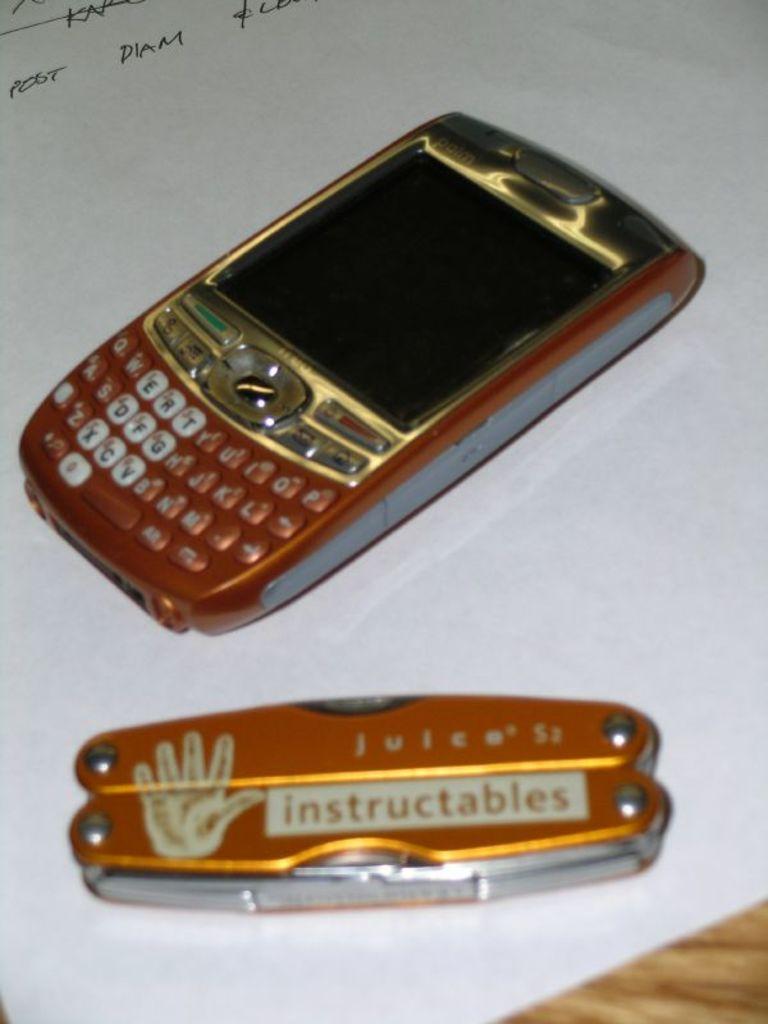What does it say above instructables?
Offer a terse response. Juice. What does the knife say written in the white rectangle?
Offer a very short reply. Instructables. 